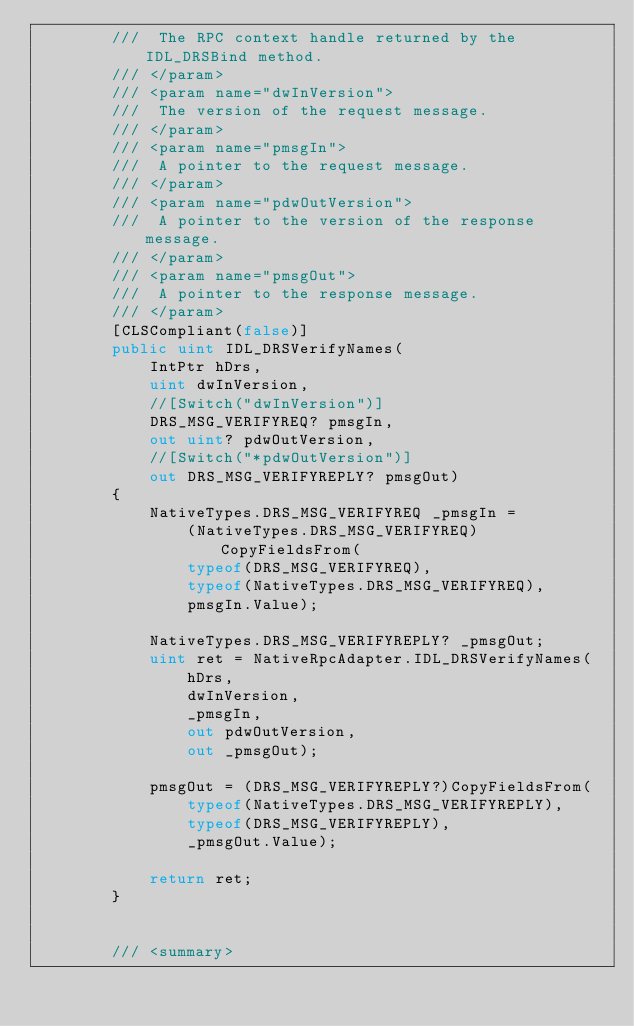<code> <loc_0><loc_0><loc_500><loc_500><_C#_>        ///  The RPC context handle returned by the IDL_DRSBind method.
        /// </param>
        /// <param name="dwInVersion">
        ///  The version of the request message.
        /// </param>
        /// <param name="pmsgIn">
        ///  A pointer to the request message.
        /// </param>
        /// <param name="pdwOutVersion">
        ///  A pointer to the version of the response message.
        /// </param>
        /// <param name="pmsgOut">
        ///  A pointer to the response message.
        /// </param>
        [CLSCompliant(false)]
        public uint IDL_DRSVerifyNames(
            IntPtr hDrs,
            uint dwInVersion,
            //[Switch("dwInVersion")] 
            DRS_MSG_VERIFYREQ? pmsgIn,
            out uint? pdwOutVersion,
            //[Switch("*pdwOutVersion")]
            out DRS_MSG_VERIFYREPLY? pmsgOut)
        {
            NativeTypes.DRS_MSG_VERIFYREQ _pmsgIn =
                (NativeTypes.DRS_MSG_VERIFYREQ)CopyFieldsFrom(
                typeof(DRS_MSG_VERIFYREQ),
                typeof(NativeTypes.DRS_MSG_VERIFYREQ),
                pmsgIn.Value);

            NativeTypes.DRS_MSG_VERIFYREPLY? _pmsgOut;
            uint ret = NativeRpcAdapter.IDL_DRSVerifyNames(
                hDrs,
                dwInVersion,
                _pmsgIn,
                out pdwOutVersion,
                out _pmsgOut);

            pmsgOut = (DRS_MSG_VERIFYREPLY?)CopyFieldsFrom(
                typeof(NativeTypes.DRS_MSG_VERIFYREPLY),
                typeof(DRS_MSG_VERIFYREPLY),
                _pmsgOut.Value);

            return ret;
        }


        /// <summary></code> 